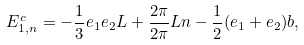Convert formula to latex. <formula><loc_0><loc_0><loc_500><loc_500>E _ { 1 , n } ^ { c } = - \frac { 1 } { 3 } e _ { 1 } e _ { 2 } L + \frac { 2 { \pi } } { 2 { \pi } } { L } n - \frac { 1 } { 2 } ( e _ { 1 } + e _ { 2 } ) b ,</formula> 